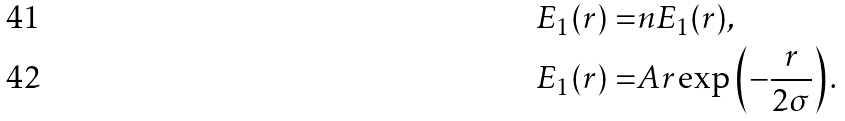Convert formula to latex. <formula><loc_0><loc_0><loc_500><loc_500>E _ { 1 } ( r ) = & n E _ { 1 } ( r ) , \\ E _ { 1 } ( r ) = & A r \exp \left ( - \frac { r } { 2 \sigma } \right ) .</formula> 